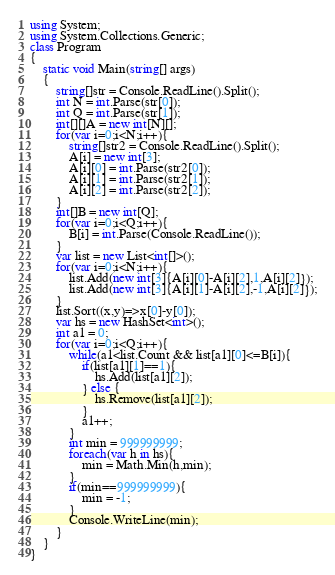<code> <loc_0><loc_0><loc_500><loc_500><_C#_>using System;
using System.Collections.Generic;
class Program
{
	static void Main(string[] args)
	{
		string[]str = Console.ReadLine().Split();
		int N = int.Parse(str[0]);
		int Q = int.Parse(str[1]);
		int[][]A = new int[N][];
		for(var i=0;i<N;i++){
			string[]str2 = Console.ReadLine().Split();
			A[i] = new int[3];
			A[i][0] = int.Parse(str2[0]);
			A[i][1] = int.Parse(str2[1]);
			A[i][2] = int.Parse(str2[2]);
		}
		int[]B = new int[Q];
		for(var i=0;i<Q;i++){
			B[i] = int.Parse(Console.ReadLine());
		}
		var list = new List<int[]>();
		for(var i=0;i<N;i++){
			list.Add(new int[3]{A[i][0]-A[i][2],1,A[i][2]});
			list.Add(new int[3]{A[i][1]-A[i][2],-1,A[i][2]});
		}
		list.Sort((x,y)=>x[0]-y[0]);
		var hs = new HashSet<int>();
		int a1 = 0;
		for(var i=0;i<Q;i++){
			while(a1<list.Count && list[a1][0]<=B[i]){
				if(list[a1][1]==1){
					hs.Add(list[a1][2]);
				} else {
					hs.Remove(list[a1][2]);
				}
				a1++;
			}
			int min = 999999999;
			foreach(var h in hs){
				min = Math.Min(h,min);
			}
			if(min==999999999){
				min = -1;
			}
			Console.WriteLine(min);	
		}
	}
}</code> 